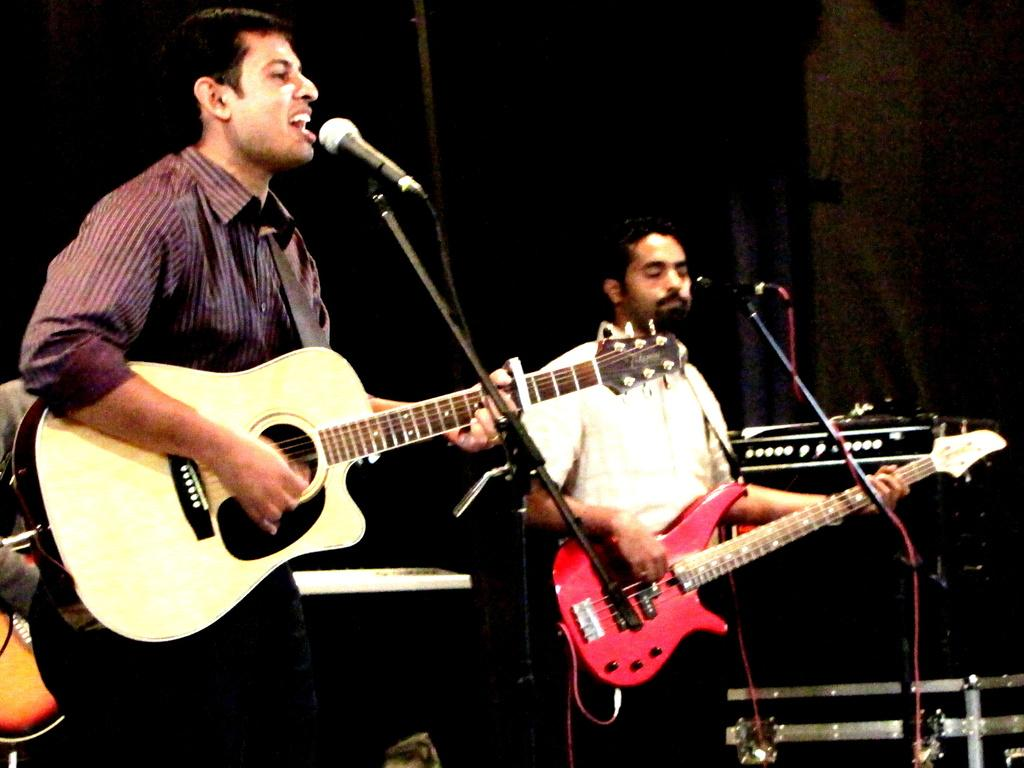How many people are in the image? There are two persons in the image. What are the two persons wearing? The two persons are wearing clothes. What are the two persons doing in the image? The two persons are playing a guitar. What objects are in front of the two persons? The two persons are standing in front of microphones. What type of silver object can be seen in the image? There is no silver object present in the image. Is the image a work of fiction or non-fiction? The image itself is neither fiction nor non-fiction; it is a photograph or illustration. 